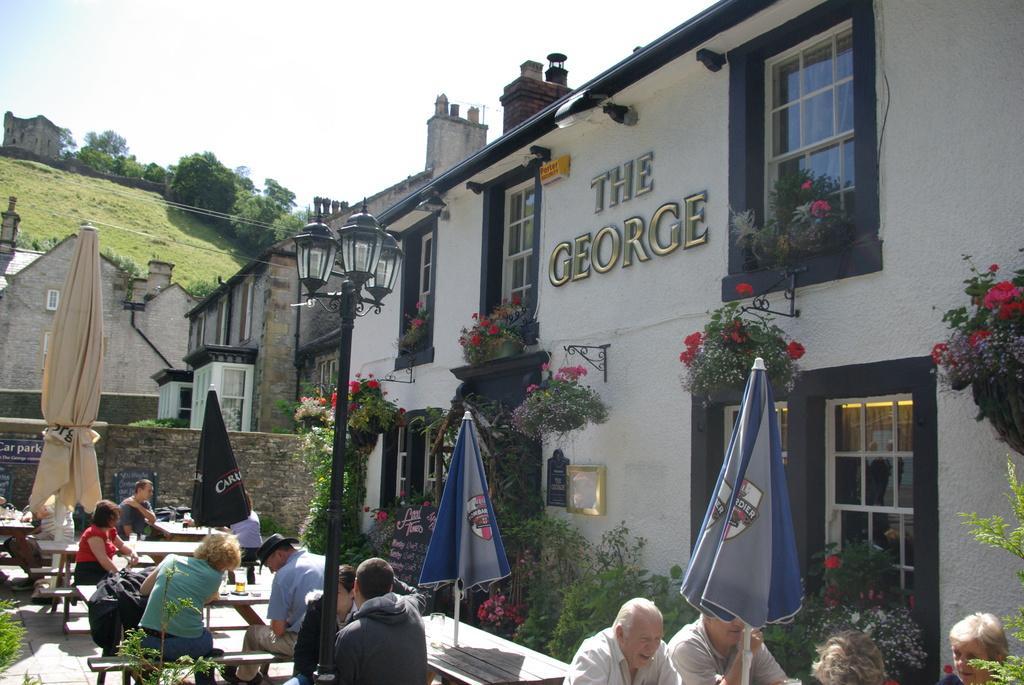Could you give a brief overview of what you see in this image? On the bottom of the image we can see a group of person sitting on the bench. On the table we can see glass, cup, plates and other object. Here we can see street light and umbrellas which is near to the tables. On the right we can see door and plants. Here we can see some red and pink color flowers. On the background we can see a building and mountain. Here we can see some trees. On the top there is a sky. 